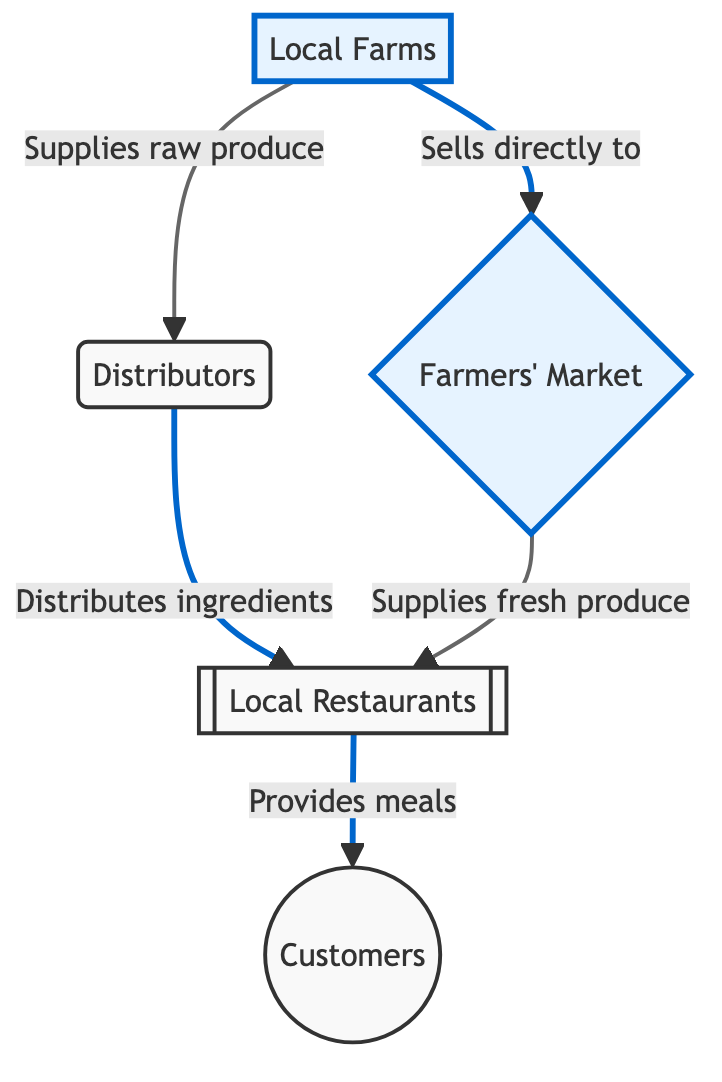What is the role of local farms in this food chain? Local farms supply raw produce to both distributors and farmers' markets, establishing their primary function as the source of ingredients needed in the food chain.
Answer: Supplies raw produce What node receives ingredients from distributors? The diagram indicates that distributors distribute ingredients to local restaurants, which denotes the interaction between these two nodes in the food chain.
Answer: Local Restaurants How many main nodes are present in the diagram? Counting the distinct main nodes – local farms, distributors, farmers' market, local restaurants, and customers – results in a total of five nodes in the food chain.
Answer: Five Which node provides meals to customers? The local restaurants node is clearly designated as the provider of meals, illustrating a direct relationship in the flow to customers.
Answer: Local Restaurants What is the direct flow from the farmers' market to local restaurants? The diagram shows that the farmers' market supplies fresh produce directly to local restaurants, indicating a direct connection in their roles.
Answer: Supplies fresh produce What is the dependency relationship between local restaurants and suppliers? Local restaurants are dependent on local farms and distributors for their supply of ingredients, reflecting a crucial link in their operational chain.
Answer: Dependent on local farms and distributors Which node has an emphasis style in the diagram? The nodes for local farms and farmers' market are highlighted with an emphasis style, indicating their importance within the food chain.
Answer: Local Farms, Farmers' Market Which two nodes interact with local restaurants? Both distributors and farmers' market interact with local restaurants, emphasizing their roles in providing ingredients for meal preparation.
Answer: Distributors, Farmers' Market What is the final outcome of the flow in this diagram? The flow culminates at the customers node, indicating that the entire food chain is ultimately aimed at providing meals to them.
Answer: Customers 